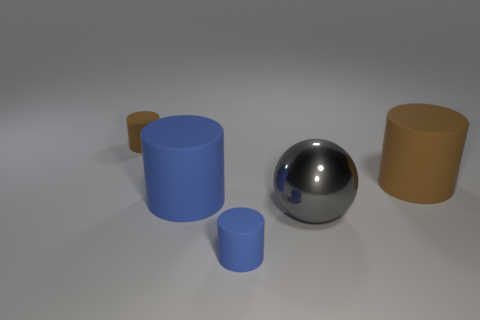Add 4 gray metallic things. How many objects exist? 9 Subtract all cylinders. How many objects are left? 1 Subtract 0 cyan cylinders. How many objects are left? 5 Subtract all big yellow shiny things. Subtract all gray metallic things. How many objects are left? 4 Add 1 small brown cylinders. How many small brown cylinders are left? 2 Add 1 large rubber objects. How many large rubber objects exist? 3 